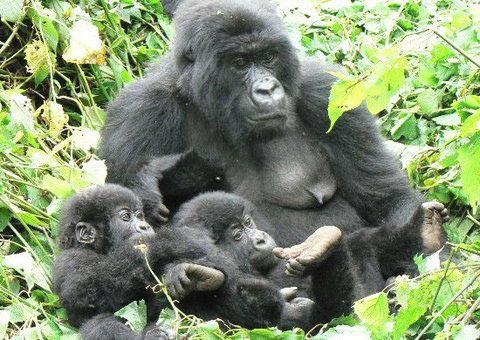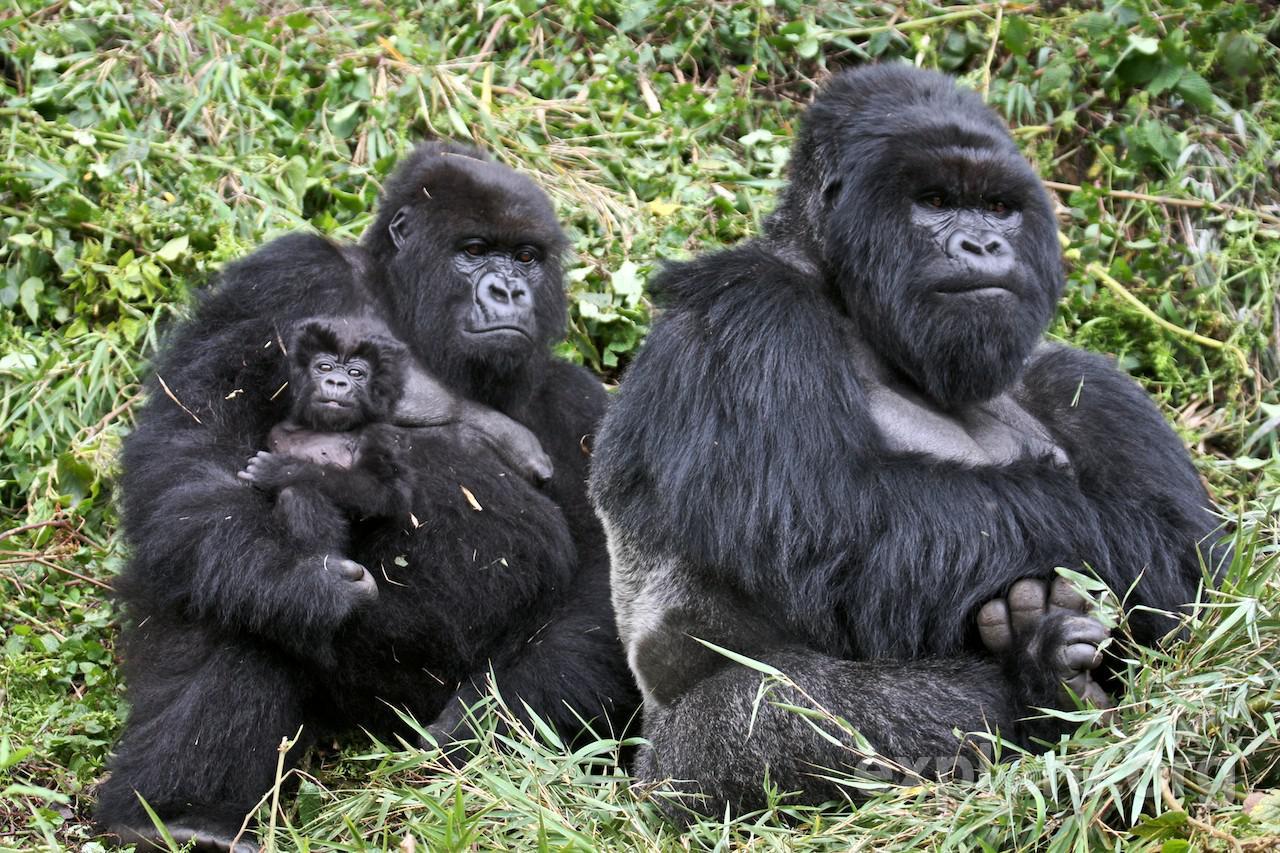The first image is the image on the left, the second image is the image on the right. Analyze the images presented: Is the assertion "One image shows a man in an olive-green shirt interacting with a gorilla." valid? Answer yes or no. No. The first image is the image on the left, the second image is the image on the right. Considering the images on both sides, is "There is a person in the image on the right." valid? Answer yes or no. No. 